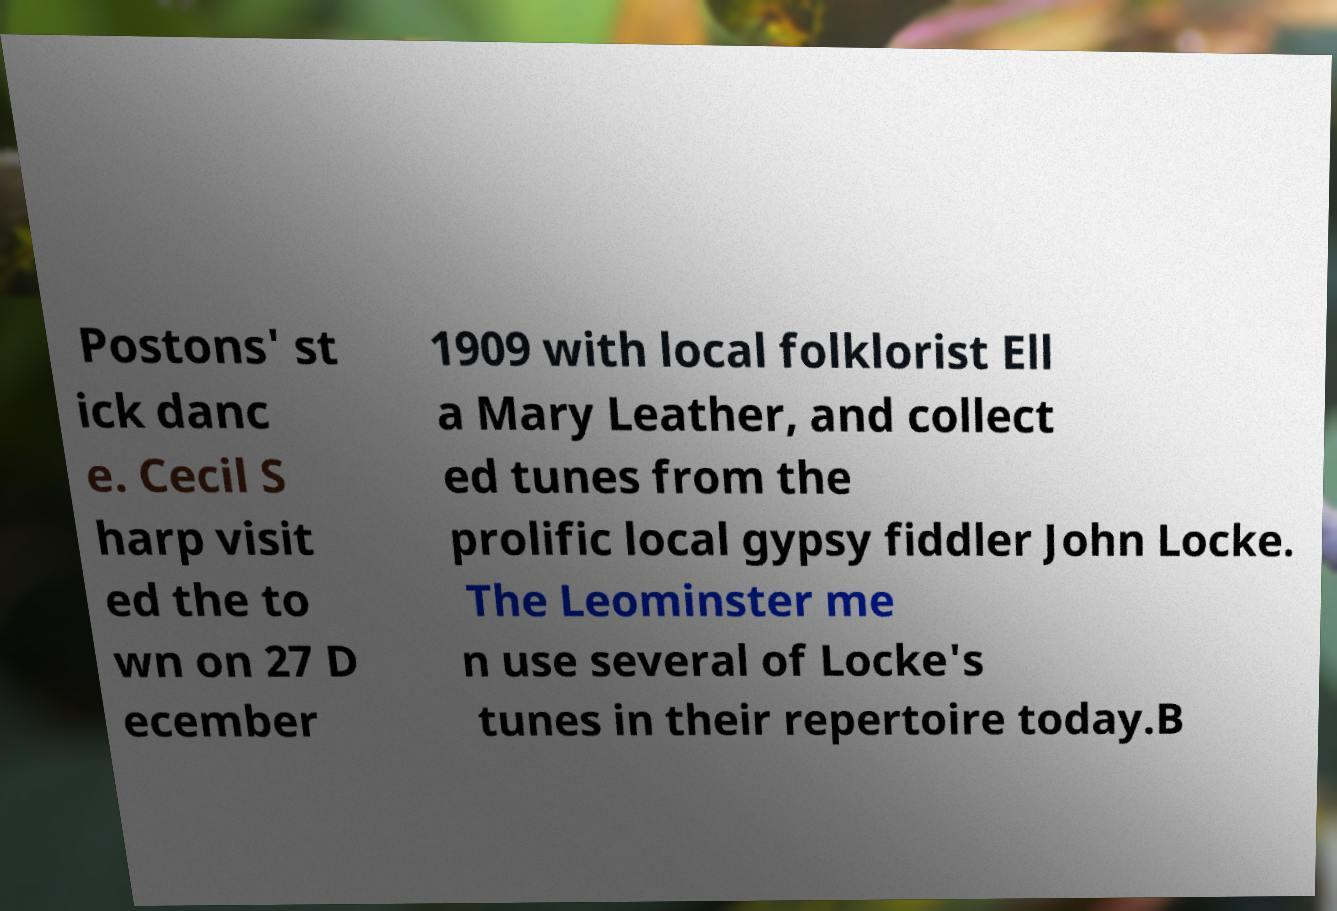Can you read and provide the text displayed in the image?This photo seems to have some interesting text. Can you extract and type it out for me? Postons' st ick danc e. Cecil S harp visit ed the to wn on 27 D ecember 1909 with local folklorist Ell a Mary Leather, and collect ed tunes from the prolific local gypsy fiddler John Locke. The Leominster me n use several of Locke's tunes in their repertoire today.B 